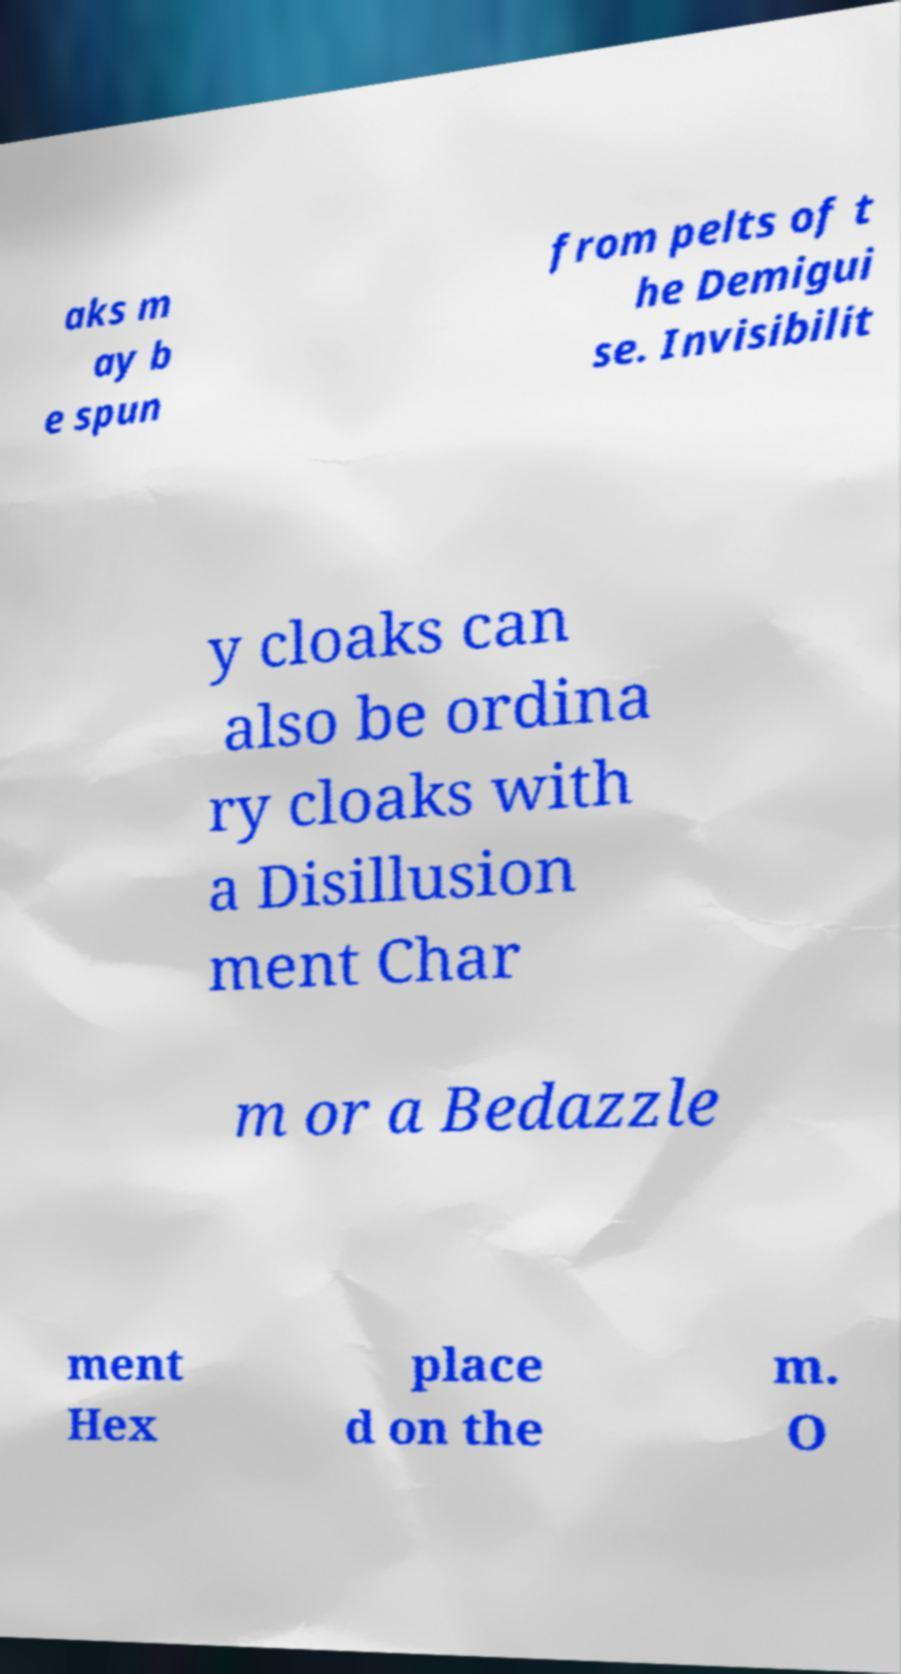Could you assist in decoding the text presented in this image and type it out clearly? aks m ay b e spun from pelts of t he Demigui se. Invisibilit y cloaks can also be ordina ry cloaks with a Disillusion ment Char m or a Bedazzle ment Hex place d on the m. O 